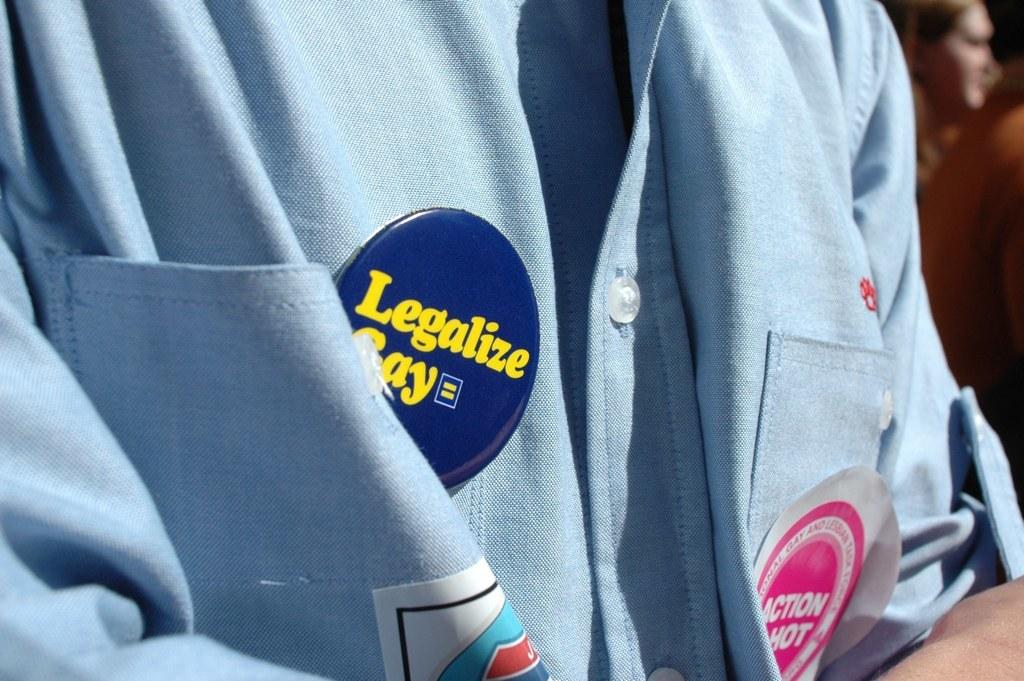What does the pink button say?
Offer a very short reply. Action hot. 